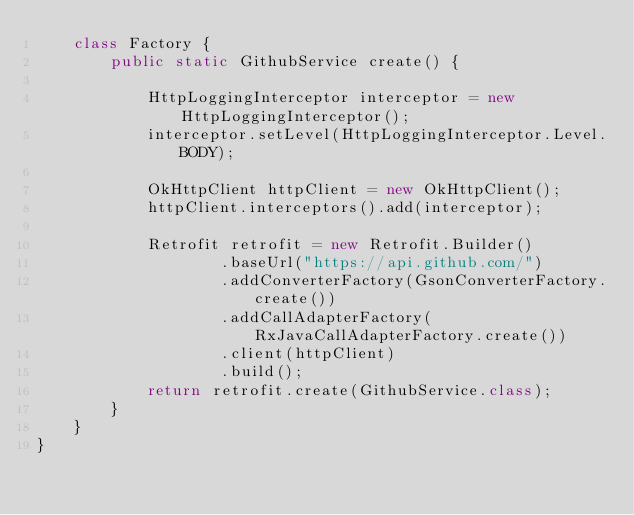Convert code to text. <code><loc_0><loc_0><loc_500><loc_500><_Java_>    class Factory {
        public static GithubService create() {

            HttpLoggingInterceptor interceptor = new HttpLoggingInterceptor();
            interceptor.setLevel(HttpLoggingInterceptor.Level.BODY);

            OkHttpClient httpClient = new OkHttpClient();
            httpClient.interceptors().add(interceptor);

            Retrofit retrofit = new Retrofit.Builder()
                    .baseUrl("https://api.github.com/")
                    .addConverterFactory(GsonConverterFactory.create())
                    .addCallAdapterFactory(RxJavaCallAdapterFactory.create())
                    .client(httpClient)
                    .build();
            return retrofit.create(GithubService.class);
        }
    }
}
</code> 